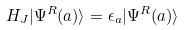<formula> <loc_0><loc_0><loc_500><loc_500>H _ { J } | \Psi ^ { R } ( a ) \rangle = \epsilon _ { a } | \Psi ^ { R } ( a ) \rangle</formula> 